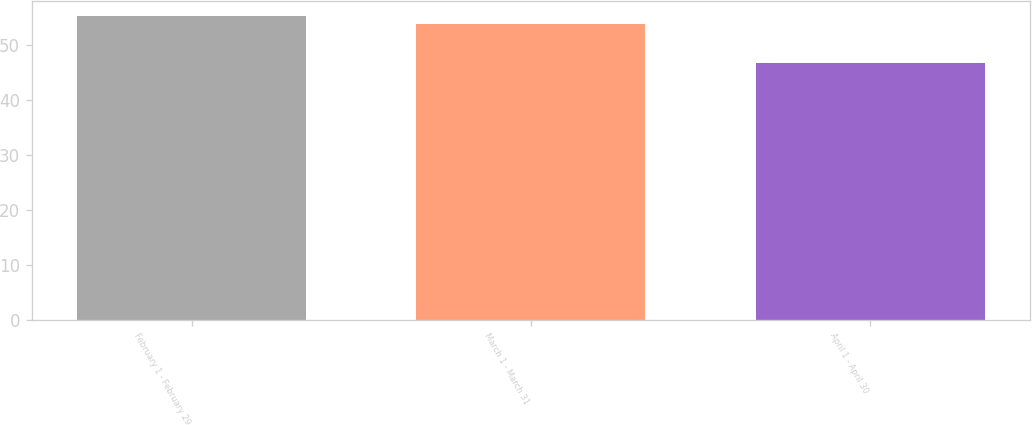<chart> <loc_0><loc_0><loc_500><loc_500><bar_chart><fcel>February 1 - February 29<fcel>March 1 - March 31<fcel>April 1 - April 30<nl><fcel>55.28<fcel>53.81<fcel>46.75<nl></chart> 